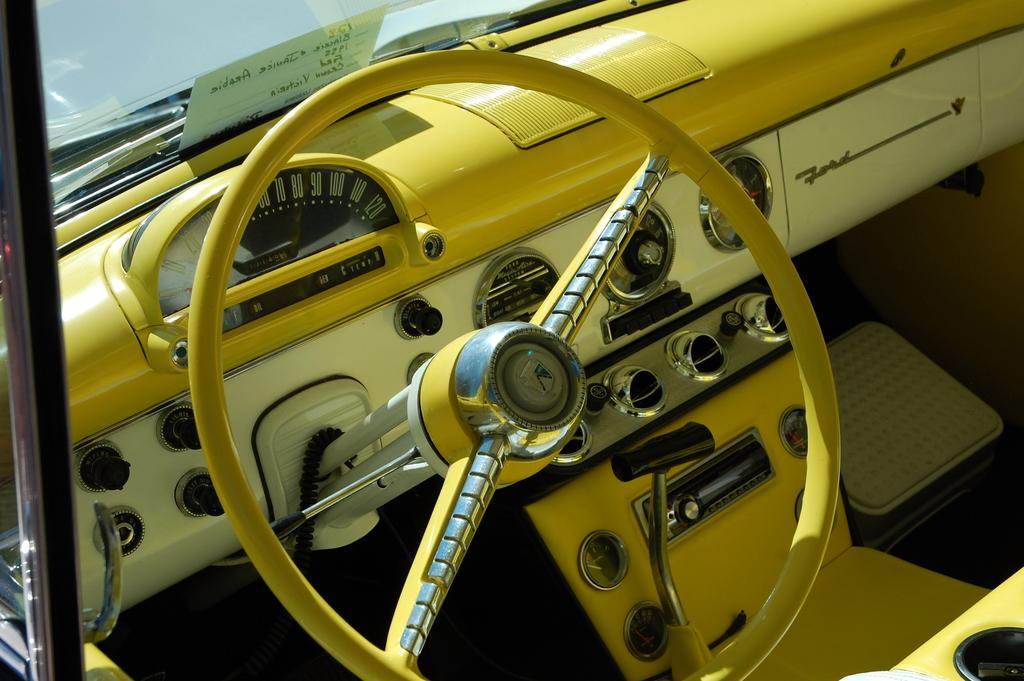What is the main object in the image? The main object in the image is a steering wheel. What else can be seen in the image related to the vehicle? The image shows a dashboard. What colors are used for the vehicle in the image? The vehicle has a yellow and white color scheme. How much zinc is present in the lettuce shown in the image? There is no lettuce or mention of zinc in the image; it features a steering wheel and a dashboard in a yellow and white vehicle. 